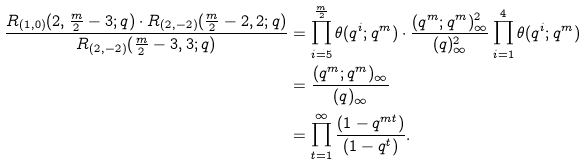Convert formula to latex. <formula><loc_0><loc_0><loc_500><loc_500>\frac { R _ { ( 1 , 0 ) } ( 2 , \frac { m } { 2 } - 3 ; q ) \cdot R _ { ( 2 , - 2 ) } ( \frac { m } { 2 } - 2 , 2 ; q ) } { R _ { ( 2 , - 2 ) } ( \frac { m } { 2 } - 3 , 3 ; q ) } & = \prod _ { i = 5 } ^ { \frac { m } { 2 } } \theta ( q ^ { i } ; q ^ { m } ) \cdot \frac { ( q ^ { m } ; q ^ { m } ) ^ { 2 } _ { \infty } } { ( q ) ^ { 2 } _ { \infty } } \prod _ { i = 1 } ^ { 4 } \theta ( q ^ { i } ; q ^ { m } ) \\ & = \frac { ( q ^ { m } ; q ^ { m } ) _ { \infty } } { ( q ) _ { \infty } } \\ & = \prod _ { t = 1 } ^ { \infty } \frac { ( 1 - q ^ { m t } ) } { ( 1 - q ^ { t } ) } .</formula> 